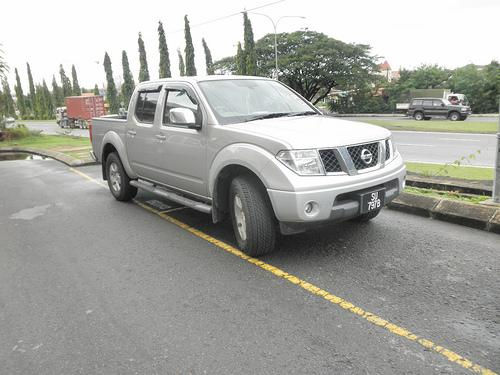What is the luxury division of this motor company?

Choices:
A) jaguar
B) lexus
C) infinity
D) acura infinity 